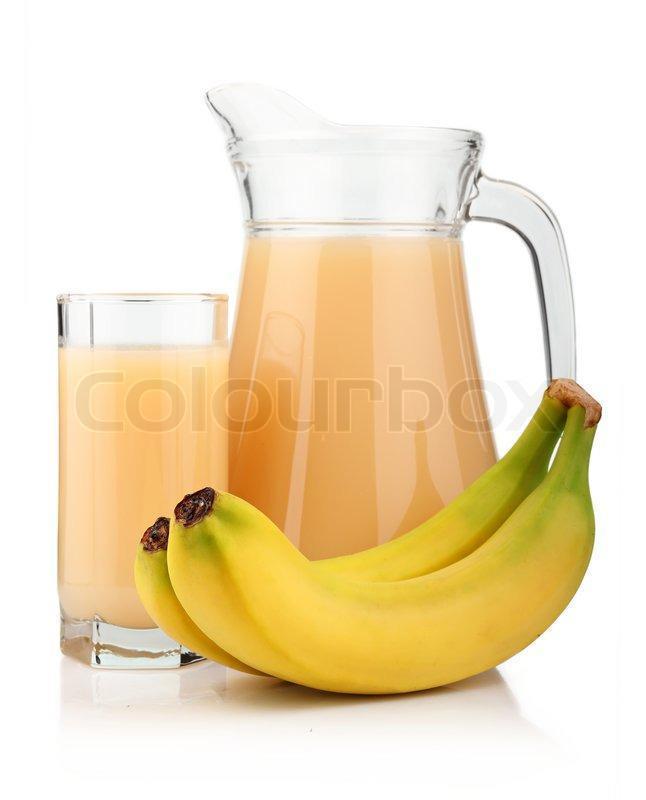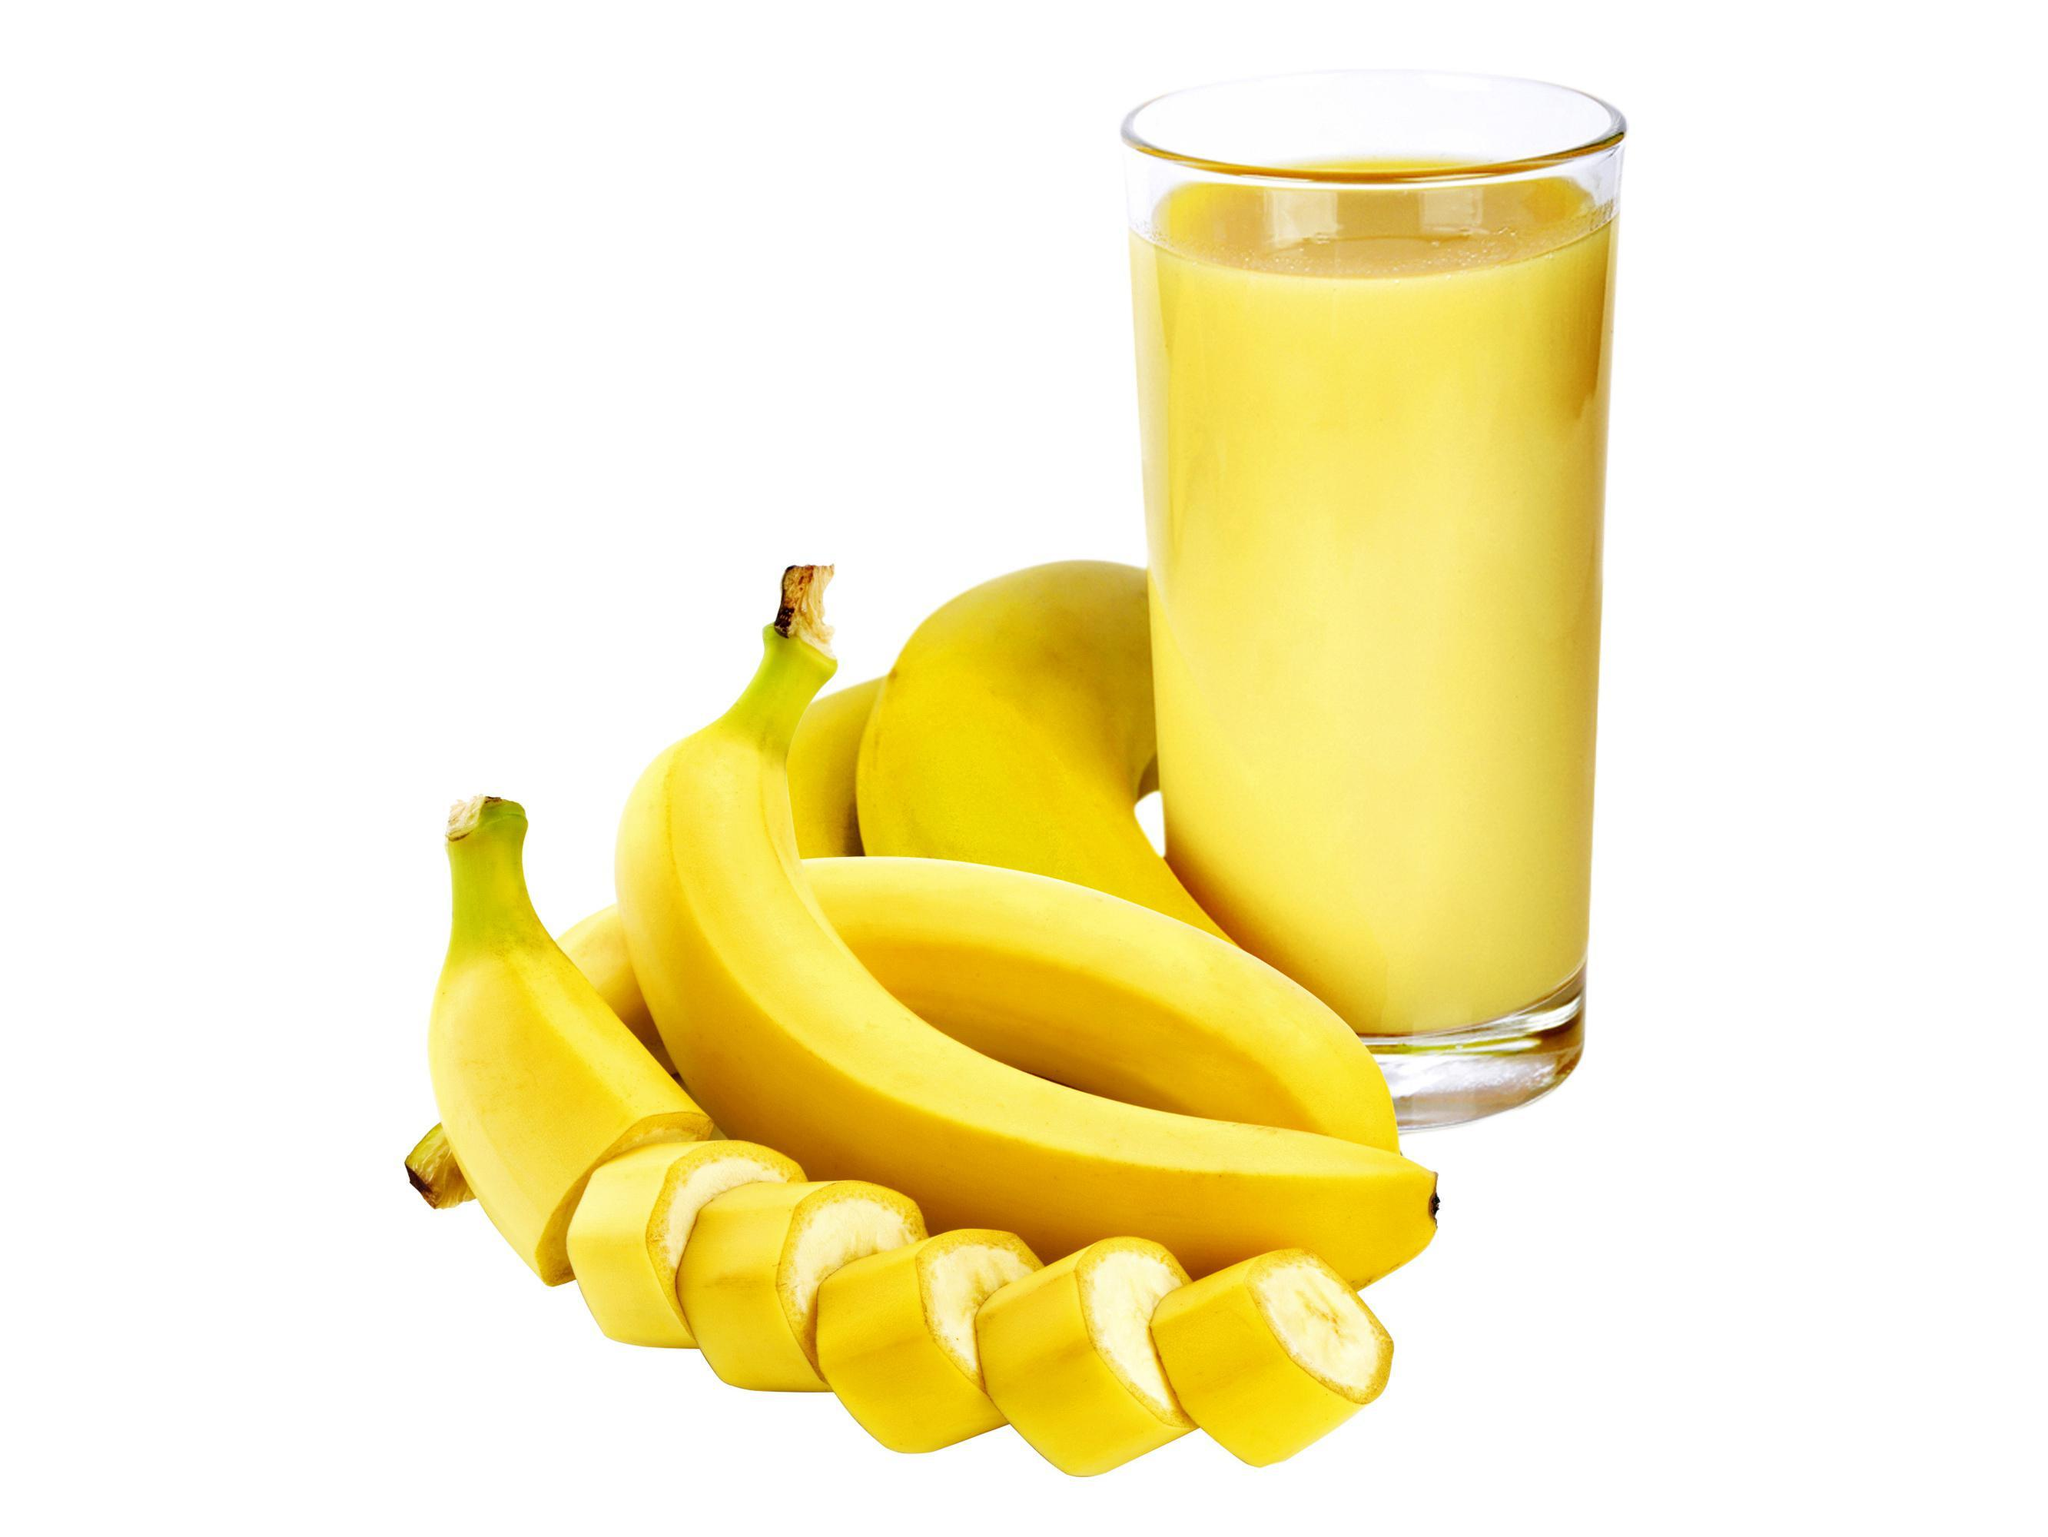The first image is the image on the left, the second image is the image on the right. For the images displayed, is the sentence "The right image contains at least one unpeeled banana." factually correct? Answer yes or no. Yes. 